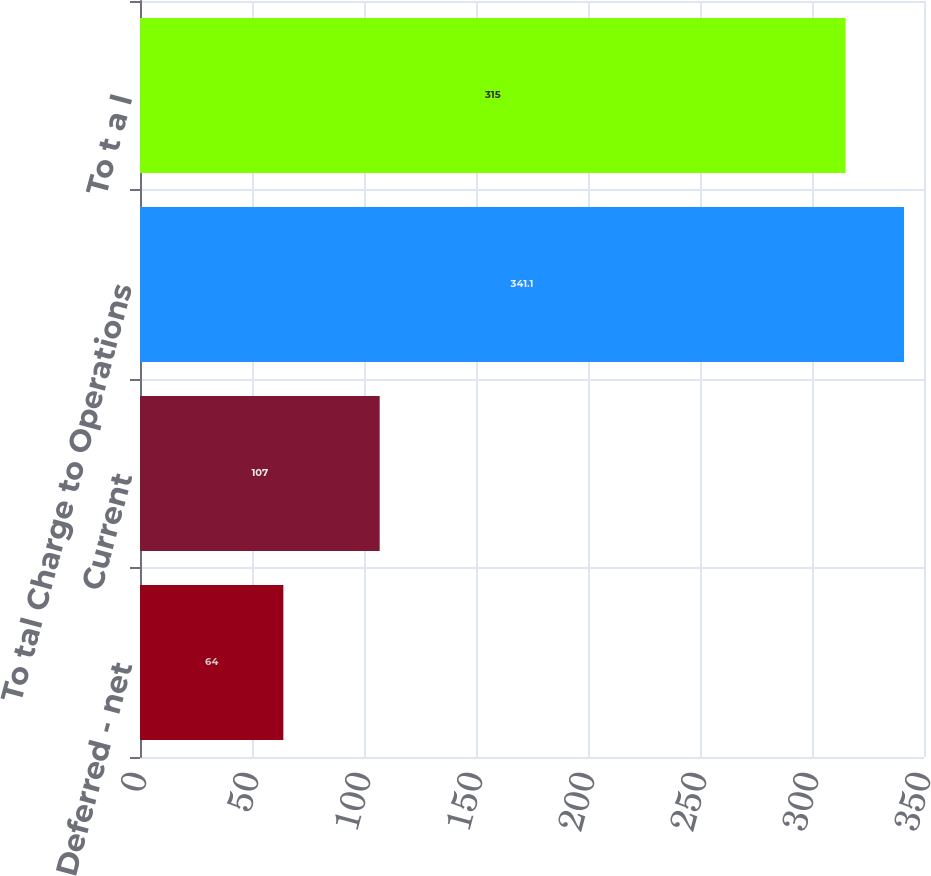Convert chart to OTSL. <chart><loc_0><loc_0><loc_500><loc_500><bar_chart><fcel>Deferred - net<fcel>Current<fcel>To tal Charge to Operations<fcel>To t a l<nl><fcel>64<fcel>107<fcel>341.1<fcel>315<nl></chart> 